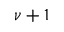<formula> <loc_0><loc_0><loc_500><loc_500>\nu + 1</formula> 